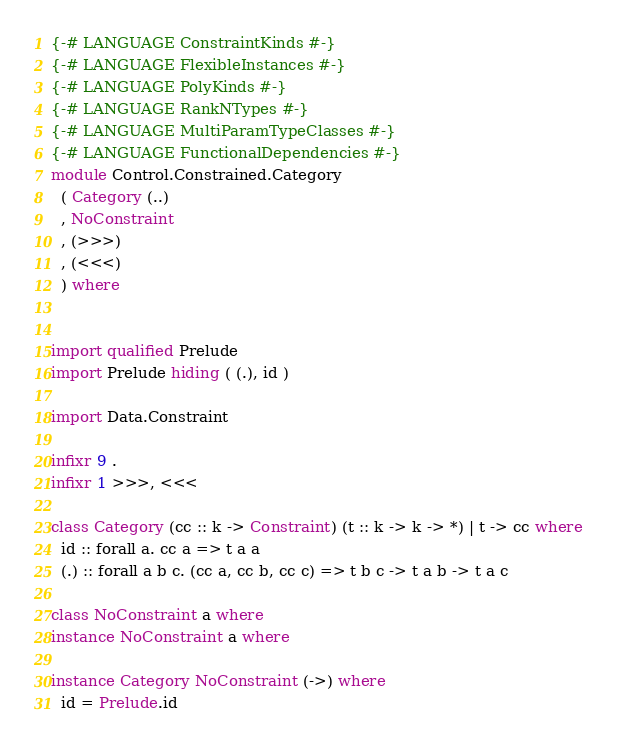Convert code to text. <code><loc_0><loc_0><loc_500><loc_500><_Haskell_>{-# LANGUAGE ConstraintKinds #-}
{-# LANGUAGE FlexibleInstances #-}
{-# LANGUAGE PolyKinds #-}
{-# LANGUAGE RankNTypes #-}
{-# LANGUAGE MultiParamTypeClasses #-}
{-# LANGUAGE FunctionalDependencies #-}
module Control.Constrained.Category
  ( Category (..)
  , NoConstraint
  , (>>>)
  , (<<<)
  ) where


import qualified Prelude
import Prelude hiding ( (.), id )

import Data.Constraint

infixr 9 .
infixr 1 >>>, <<<

class Category (cc :: k -> Constraint) (t :: k -> k -> *) | t -> cc where
  id :: forall a. cc a => t a a
  (.) :: forall a b c. (cc a, cc b, cc c) => t b c -> t a b -> t a c

class NoConstraint a where
instance NoConstraint a where

instance Category NoConstraint (->) where
  id = Prelude.id</code> 